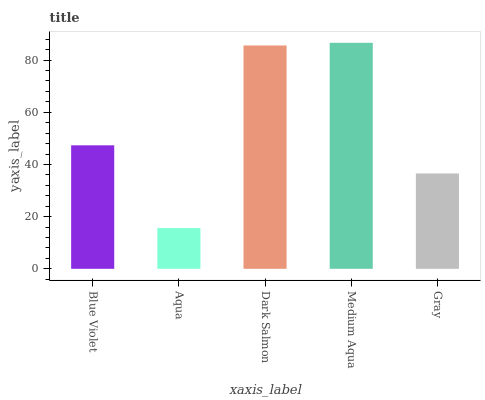Is Aqua the minimum?
Answer yes or no. Yes. Is Medium Aqua the maximum?
Answer yes or no. Yes. Is Dark Salmon the minimum?
Answer yes or no. No. Is Dark Salmon the maximum?
Answer yes or no. No. Is Dark Salmon greater than Aqua?
Answer yes or no. Yes. Is Aqua less than Dark Salmon?
Answer yes or no. Yes. Is Aqua greater than Dark Salmon?
Answer yes or no. No. Is Dark Salmon less than Aqua?
Answer yes or no. No. Is Blue Violet the high median?
Answer yes or no. Yes. Is Blue Violet the low median?
Answer yes or no. Yes. Is Aqua the high median?
Answer yes or no. No. Is Medium Aqua the low median?
Answer yes or no. No. 